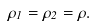Convert formula to latex. <formula><loc_0><loc_0><loc_500><loc_500>\rho _ { 1 } = \rho _ { 2 } = \rho .</formula> 